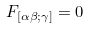<formula> <loc_0><loc_0><loc_500><loc_500>F _ { [ \alpha \beta ; \gamma ] } = 0</formula> 